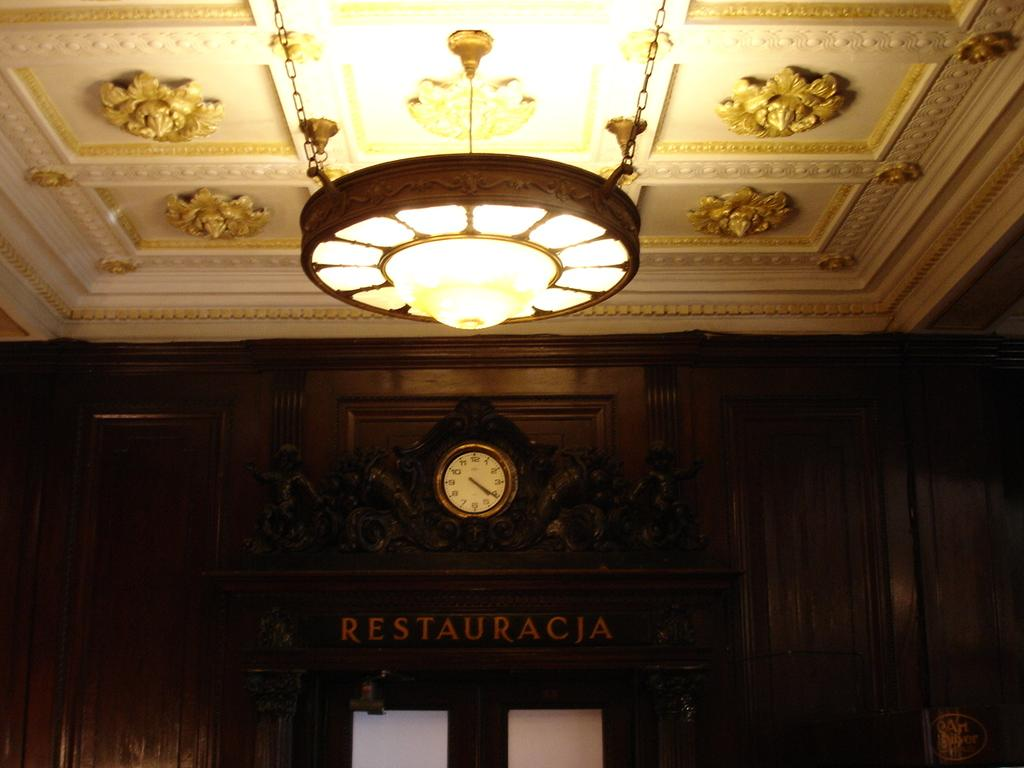<image>
Relay a brief, clear account of the picture shown. An ornate lobby with a sign reading restauracja over some doors. 